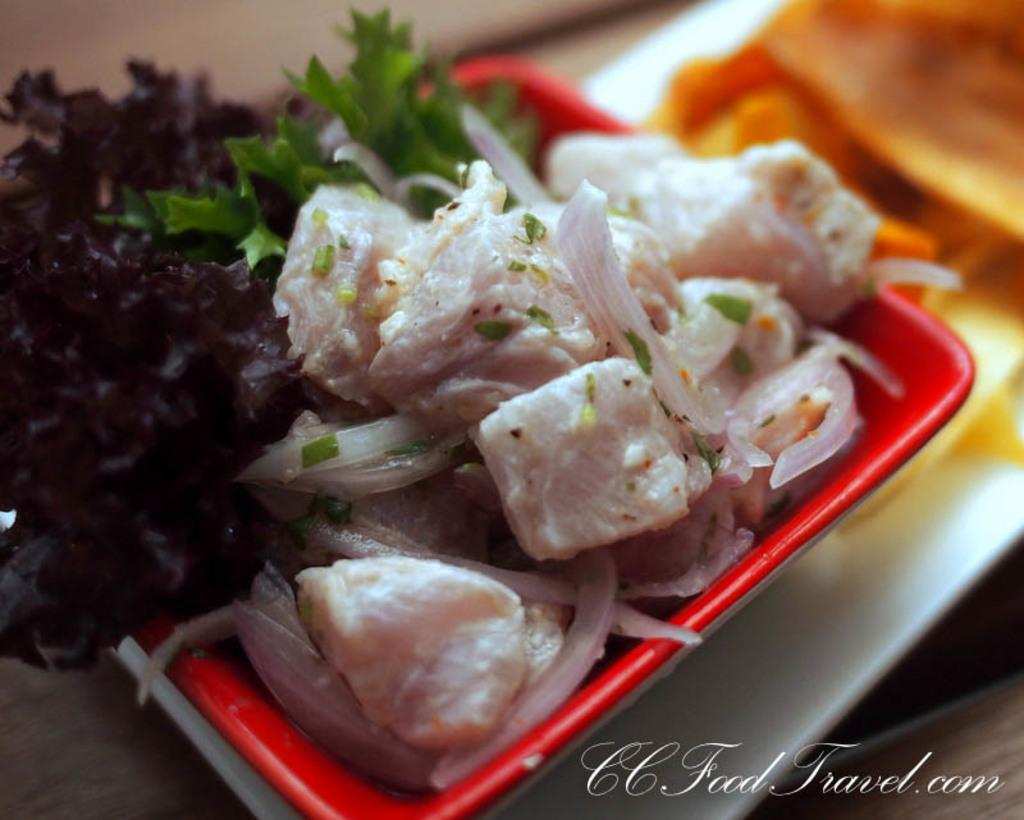What is in the bowl that is visible in the image? The bowl contains meat pieces and green leaves. What other items can be seen in the image besides the bowl? There is a white plate at the bottom of the image. What is on the white plate in the image? The white plate has food on it. What type of lumber is used to construct the bowl in the image? The image does not provide information about the construction material of the bowl, and there is no lumber visible in the image. 